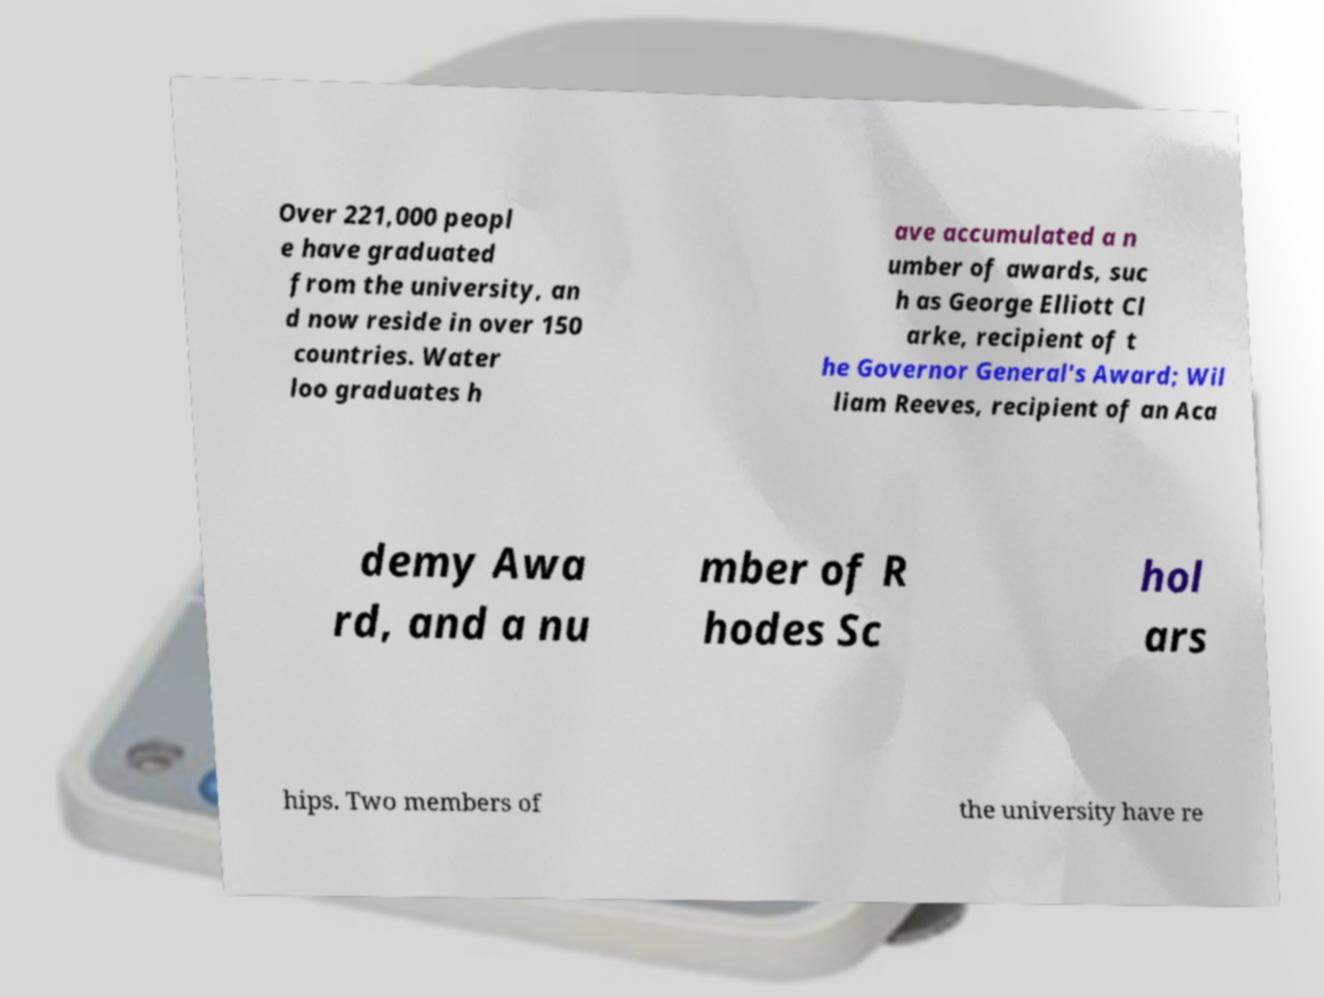I need the written content from this picture converted into text. Can you do that? Over 221,000 peopl e have graduated from the university, an d now reside in over 150 countries. Water loo graduates h ave accumulated a n umber of awards, suc h as George Elliott Cl arke, recipient of t he Governor General's Award; Wil liam Reeves, recipient of an Aca demy Awa rd, and a nu mber of R hodes Sc hol ars hips. Two members of the university have re 